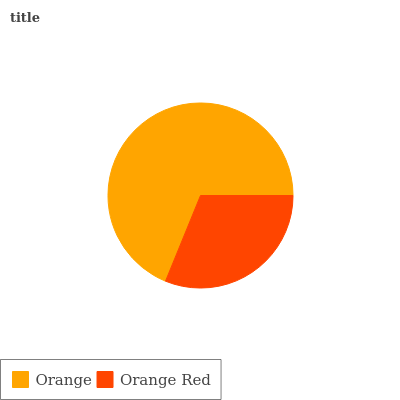Is Orange Red the minimum?
Answer yes or no. Yes. Is Orange the maximum?
Answer yes or no. Yes. Is Orange Red the maximum?
Answer yes or no. No. Is Orange greater than Orange Red?
Answer yes or no. Yes. Is Orange Red less than Orange?
Answer yes or no. Yes. Is Orange Red greater than Orange?
Answer yes or no. No. Is Orange less than Orange Red?
Answer yes or no. No. Is Orange the high median?
Answer yes or no. Yes. Is Orange Red the low median?
Answer yes or no. Yes. Is Orange Red the high median?
Answer yes or no. No. Is Orange the low median?
Answer yes or no. No. 